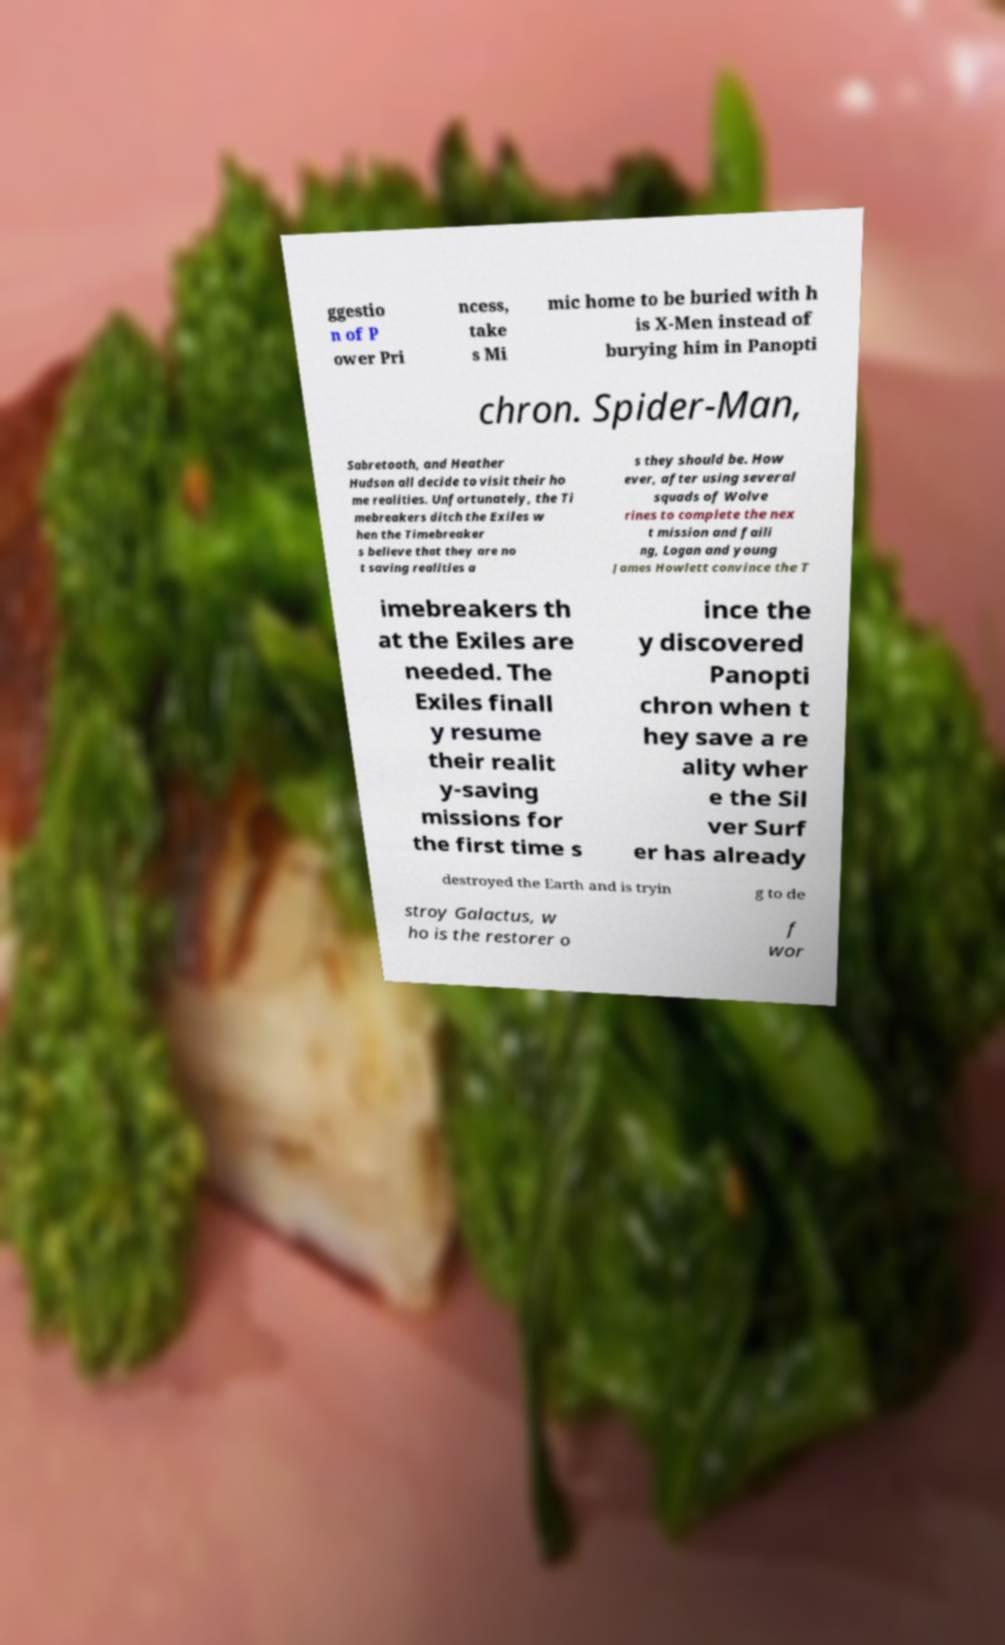For documentation purposes, I need the text within this image transcribed. Could you provide that? ggestio n of P ower Pri ncess, take s Mi mic home to be buried with h is X-Men instead of burying him in Panopti chron. Spider-Man, Sabretooth, and Heather Hudson all decide to visit their ho me realities. Unfortunately, the Ti mebreakers ditch the Exiles w hen the Timebreaker s believe that they are no t saving realities a s they should be. How ever, after using several squads of Wolve rines to complete the nex t mission and faili ng, Logan and young James Howlett convince the T imebreakers th at the Exiles are needed. The Exiles finall y resume their realit y-saving missions for the first time s ince the y discovered Panopti chron when t hey save a re ality wher e the Sil ver Surf er has already destroyed the Earth and is tryin g to de stroy Galactus, w ho is the restorer o f wor 